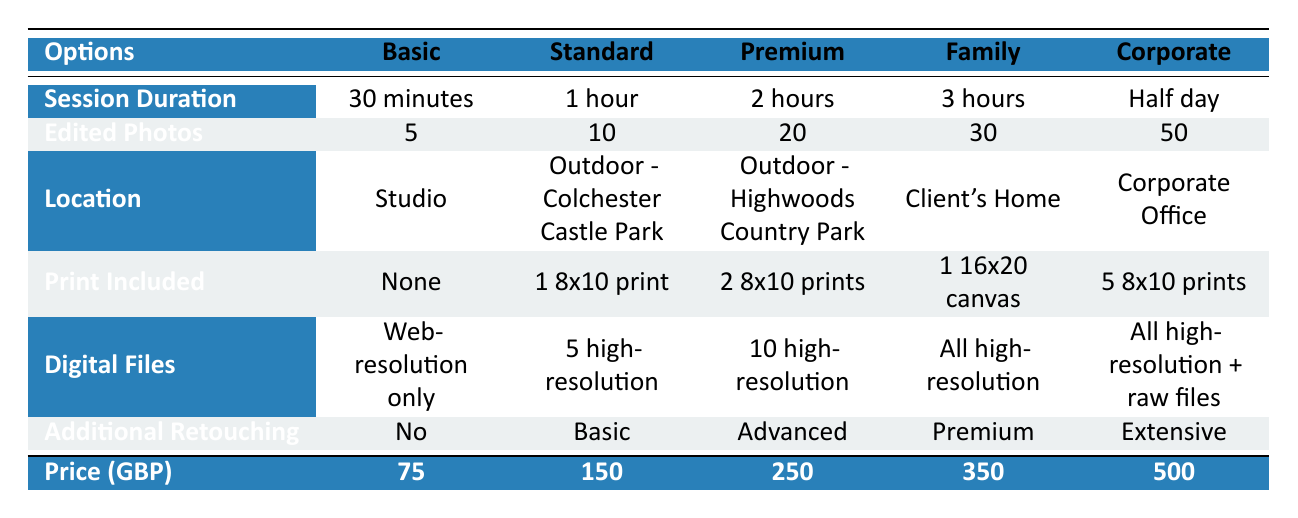What is the duration of the Family package? The Family package is listed under the "Session Duration" row, where its value shows "3 hours."
Answer: 3 hours How many edited photos do you get with the Premium package? The Premium package corresponds to the "Edited Photos" row, which states "20."
Answer: 20 Does the Corporate package include any prints? Looking at the "Print Included" row, the Corporate package has "5 8x10 prints," indicating that prints are included.
Answer: Yes What is the price difference between the Basic and Premium packages? The Basic package costs 75 GBP and the Premium package costs 250 GBP. The difference is 250 - 75 = 175.
Answer: 175 GBP Which package offers the most digital files? The Corporate package offers "All high-resolution + raw files," which is more than any other package.
Answer: Corporate Is there any package that offers extensive additional retouching? The Additional Retouching row shows that only the Corporate package has "Extensive" retouching, confirming there is such an option.
Answer: Yes What is the total number of edited photos across all packages? Adding the edited photos from each package gives: 5 + 10 + 20 + 30 + 50 = 115.
Answer: 115 Which location is associated with the Standard package? The Standard package corresponds to the "Location" row, indicating "Outdoor - Colchester Castle Park."
Answer: Outdoor - Colchester Castle Park How does the session duration for the Basic package compare to the duration for the Family package? The duration for the Basic package is "30 minutes," while the Family package's duration is "3 hours." This indicates the Family package has a longer duration by 2 hours and 30 minutes.
Answer: 3 hours longer 